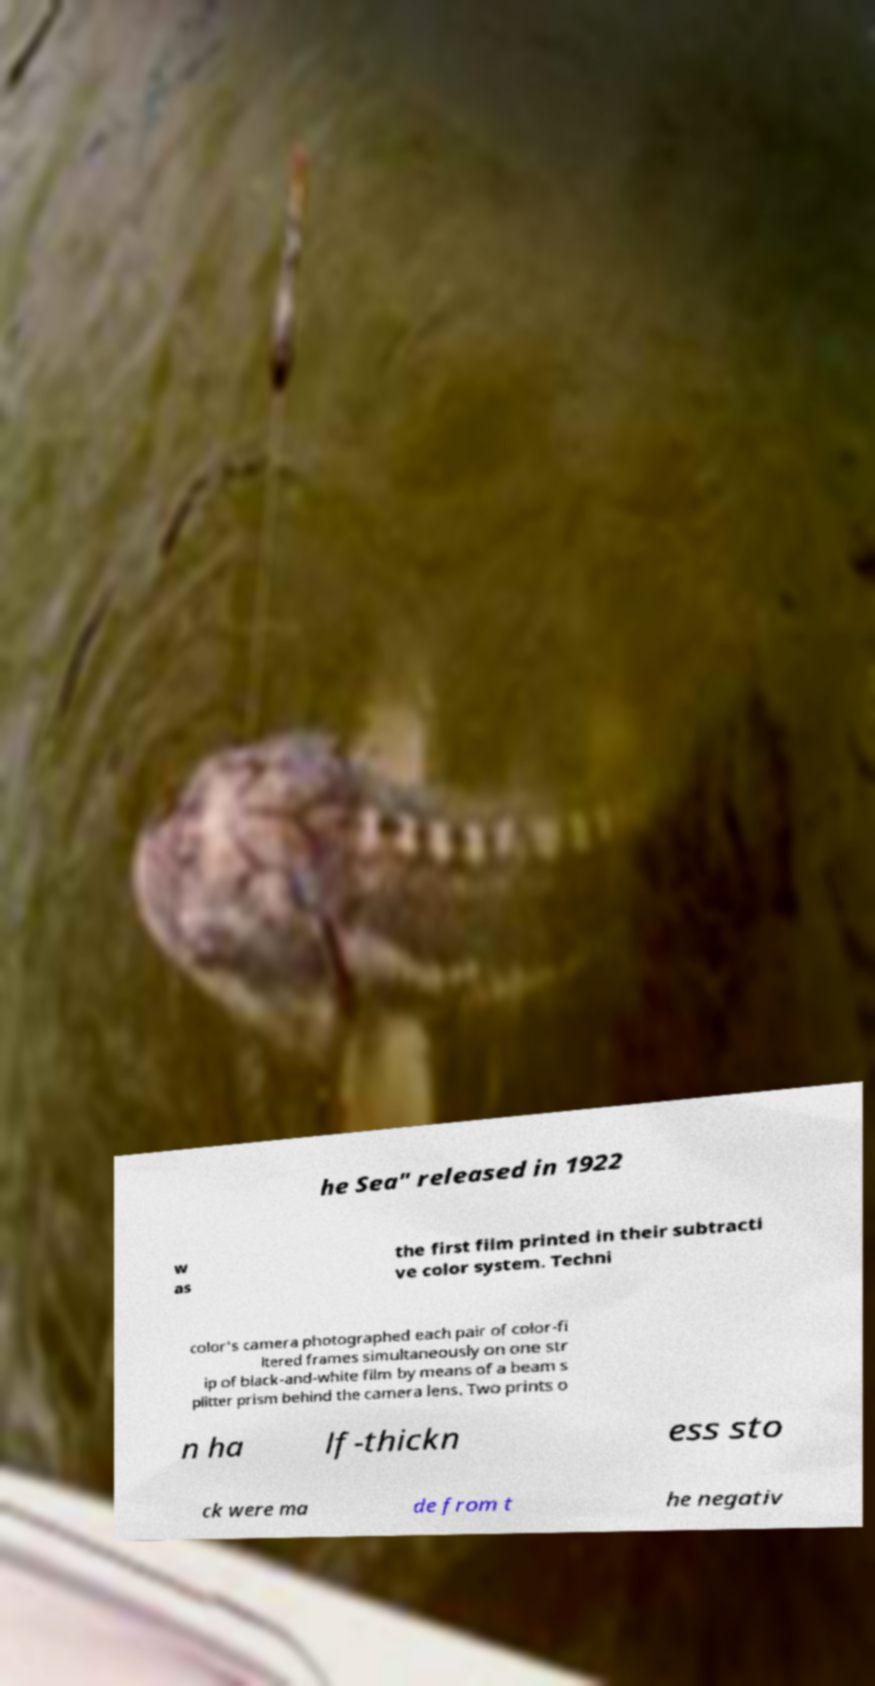Could you assist in decoding the text presented in this image and type it out clearly? he Sea" released in 1922 w as the first film printed in their subtracti ve color system. Techni color's camera photographed each pair of color-fi ltered frames simultaneously on one str ip of black-and-white film by means of a beam s plitter prism behind the camera lens. Two prints o n ha lf-thickn ess sto ck were ma de from t he negativ 